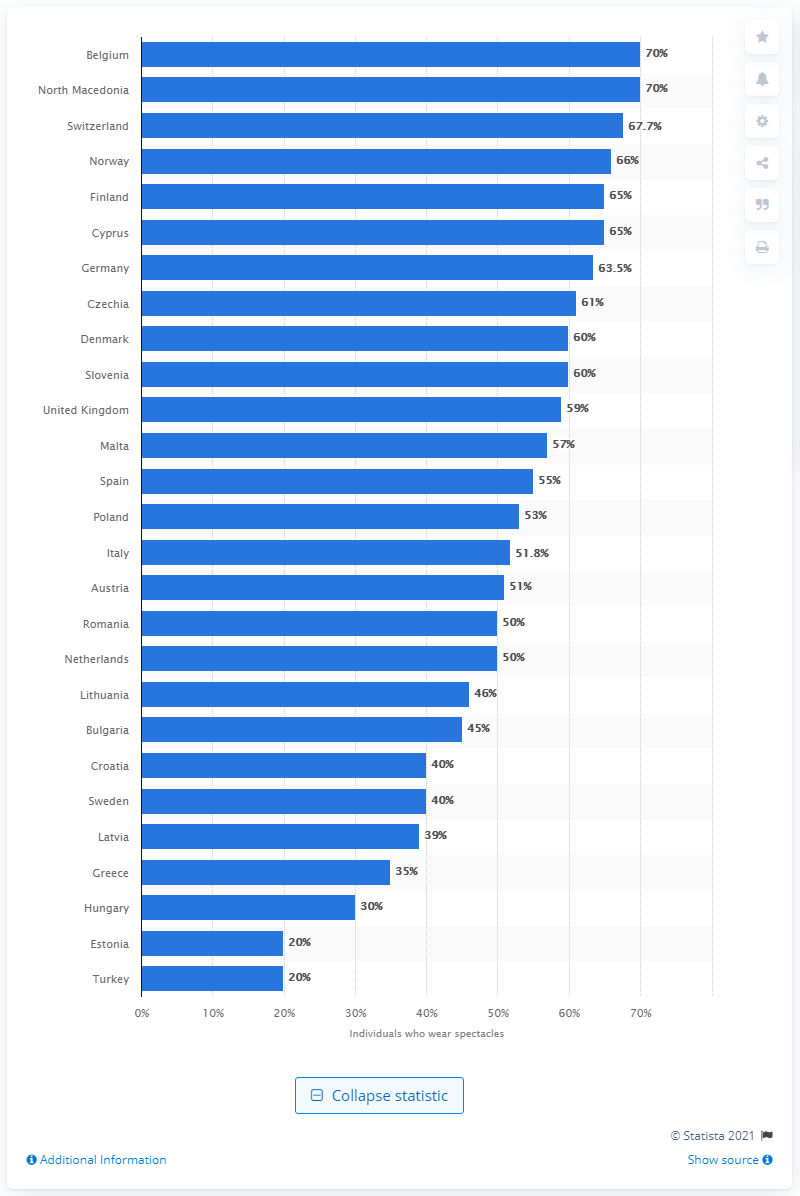Specify some key components in this picture. According to statistics, Norway had the highest percentage of people wearing spectacles in 2020. In 2020, it was estimated that approximately 67.7% of the population of Switzerland wore spectacles. 